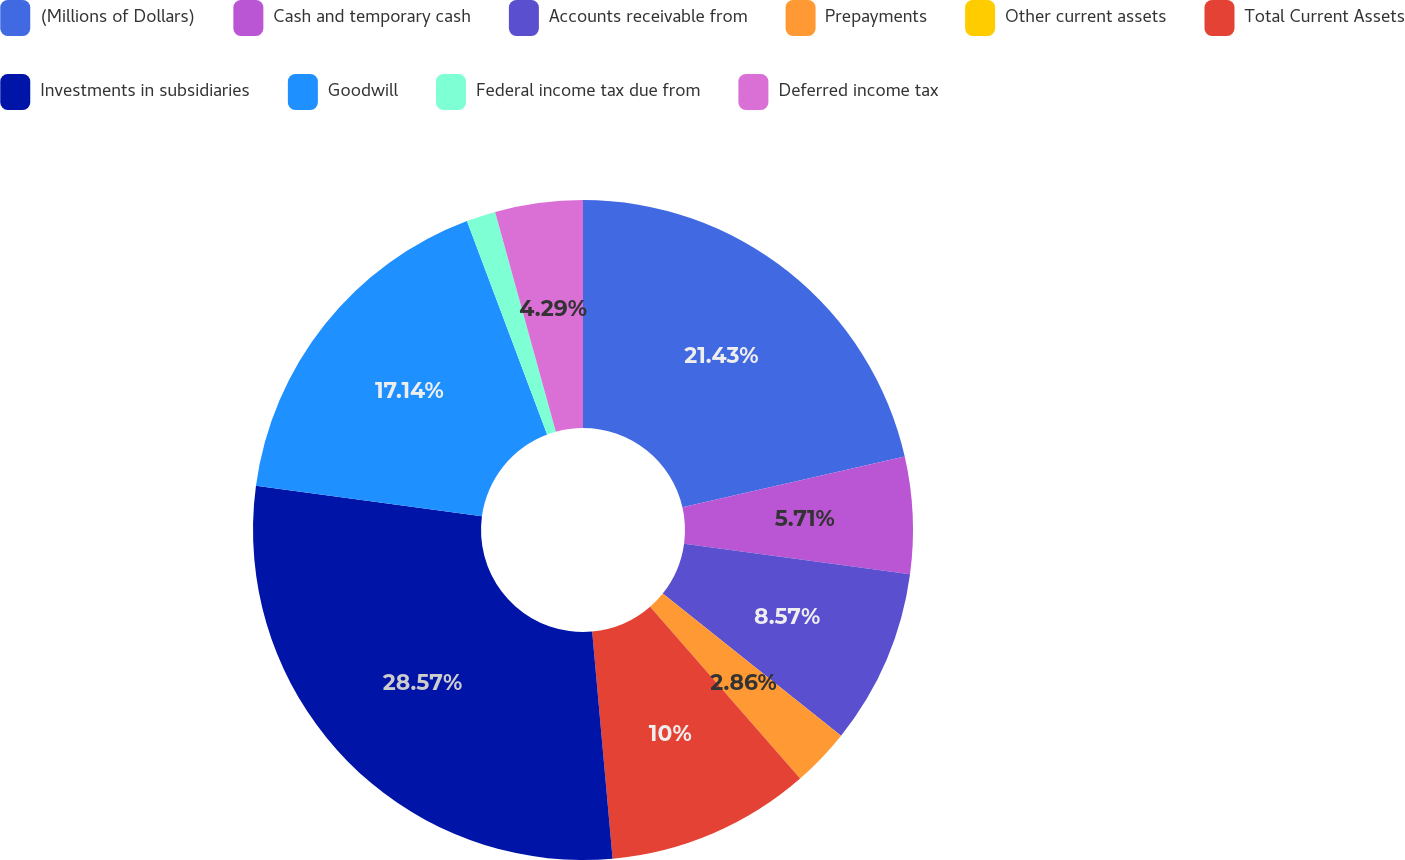<chart> <loc_0><loc_0><loc_500><loc_500><pie_chart><fcel>(Millions of Dollars)<fcel>Cash and temporary cash<fcel>Accounts receivable from<fcel>Prepayments<fcel>Other current assets<fcel>Total Current Assets<fcel>Investments in subsidiaries<fcel>Goodwill<fcel>Federal income tax due from<fcel>Deferred income tax<nl><fcel>21.43%<fcel>5.71%<fcel>8.57%<fcel>2.86%<fcel>0.0%<fcel>10.0%<fcel>28.57%<fcel>17.14%<fcel>1.43%<fcel>4.29%<nl></chart> 